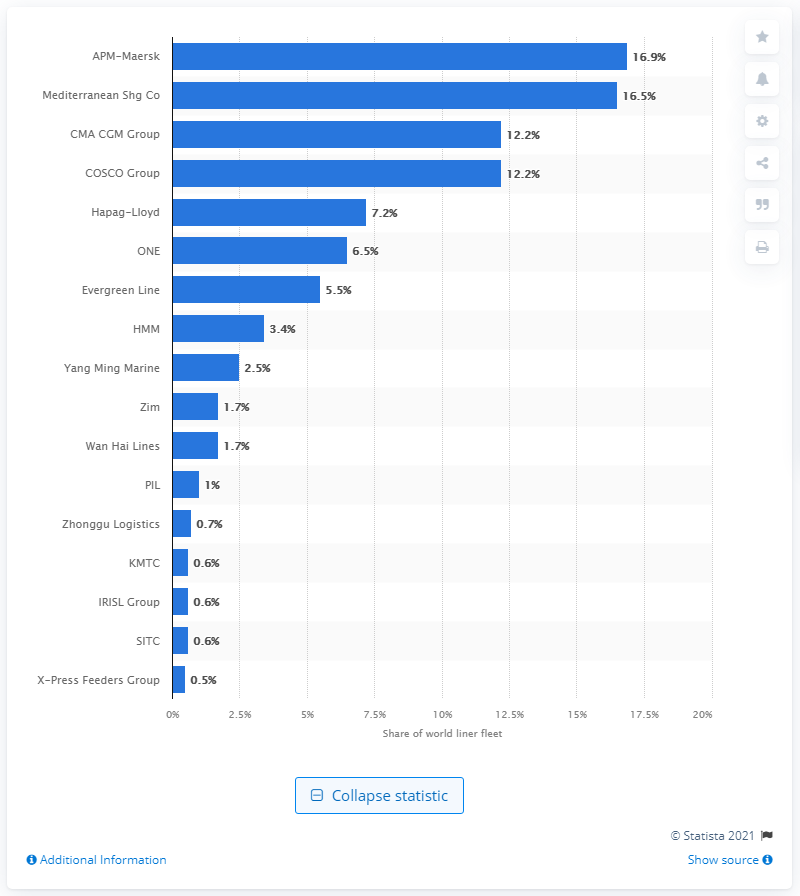Outline some significant characteristics in this image. The Mediterranean Shipping Company had a share of 16.5% of the world's liner fleet. 